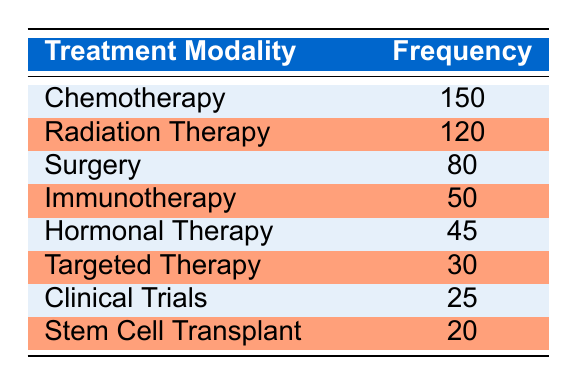What is the frequency of chemotherapy used? The table lists chemotherapy with a frequency of 150.
Answer: 150 Which treatment modality has the lowest frequency? Among all modalities listed, stem cell transplant has the lowest frequency of 20.
Answer: Stem Cell Transplant How many more patients received radiation therapy than hormonal therapy? The frequency for radiation therapy is 120 and for hormonal therapy is 45. The difference is 120 - 45 = 75.
Answer: 75 Is the frequency of immunotherapy greater than the frequency of targeted therapy? Immunotherapy has a frequency of 50 while targeted therapy has a frequency of 30. Since 50 is greater than 30, the statement is true.
Answer: Yes What is the total frequency of treatments (sum of all modalities)? Adding the frequencies together: 150 (chemotherapy) + 120 (radiation) + 80 (surgery) + 50 (immunotherapy) + 45 (hormonal) + 30 (targeted) + 25 (clinical trials) + 20 (stem cell transplant) = 520.
Answer: 520 What percentage of patients received surgery compared to those who received chemotherapy? Surgery frequency is 80 and chemotherapy is 150. To find the percentage, calculate (80/150) * 100 = 53.33%.
Answer: 53.33% Are more patients treated with chemotherapy and surgery combined than those treated with hormonal therapy and stem cell transplant combined? The combined frequency for chemotherapy and surgery is 150 + 80 = 230, while for hormonal therapy and stem cell transplant it is 45 + 20 = 65. Since 230 is greater than 65, the answer is yes.
Answer: Yes What is the average frequency of all treatment modalities? To calculate the average, add all frequencies (520, as calculated before) and divide by the number of modalities (8): 520 / 8 = 65.
Answer: 65 Which treatment modality has a frequency within the range of 40 to 60? The frequencies listed are: Chemotherapy (150), Radiation Therapy (120), Surgery (80), Immunotherapy (50), Hormonal Therapy (45), Targeted Therapy (30), Clinical Trials (25), and Stem Cell Transplant (20). The modalities within the range are immunotherapy (50) and hormonal therapy (45).
Answer: Immunotherapy and Hormonal Therapy 